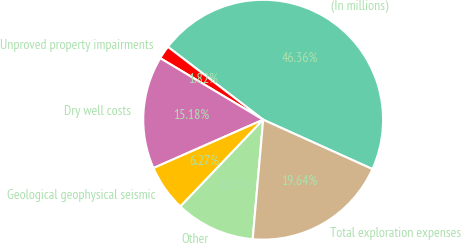Convert chart to OTSL. <chart><loc_0><loc_0><loc_500><loc_500><pie_chart><fcel>(In millions)<fcel>Unproved property impairments<fcel>Dry well costs<fcel>Geological geophysical seismic<fcel>Other<fcel>Total exploration expenses<nl><fcel>46.36%<fcel>1.82%<fcel>15.18%<fcel>6.27%<fcel>10.73%<fcel>19.64%<nl></chart> 